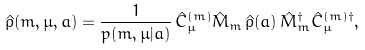<formula> <loc_0><loc_0><loc_500><loc_500>\hat { \rho } ( m , \mu , a ) = \frac { 1 } { p ( m , \mu | a ) } \, \hat { C } ^ { ( m ) } _ { \mu } \hat { M } _ { m } \, \hat { \rho } ( a ) \, \hat { M } _ { m } ^ { \dagger } \hat { C } ^ { ( m ) \dagger } _ { \mu } ,</formula> 